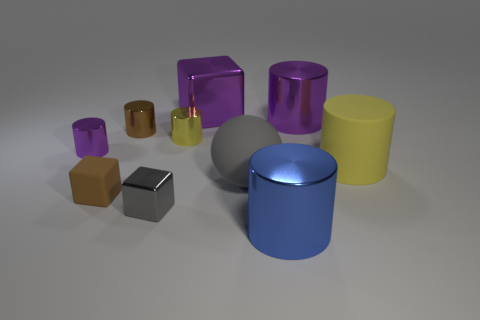Subtract all blue shiny cylinders. How many cylinders are left? 5 Subtract all blue cylinders. How many cylinders are left? 5 Subtract all brown cylinders. Subtract all green spheres. How many cylinders are left? 5 Subtract all balls. How many objects are left? 9 Subtract 1 gray spheres. How many objects are left? 9 Subtract all tiny yellow shiny cubes. Subtract all tiny brown rubber objects. How many objects are left? 9 Add 4 tiny things. How many tiny things are left? 9 Add 6 big gray cylinders. How many big gray cylinders exist? 6 